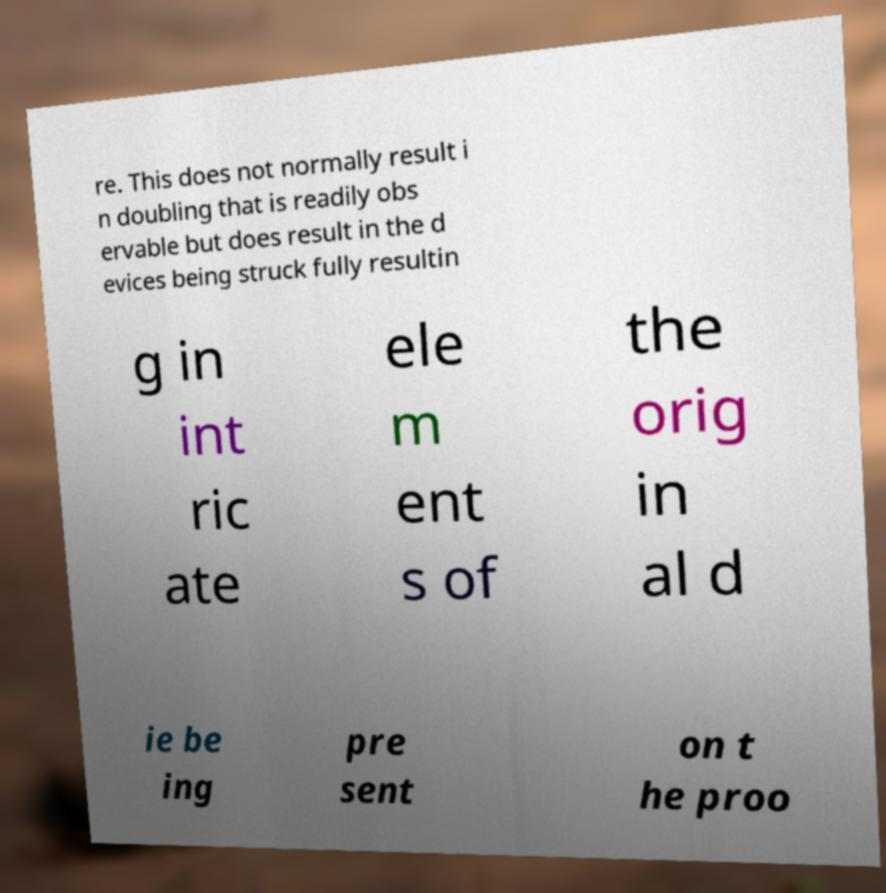Please identify and transcribe the text found in this image. re. This does not normally result i n doubling that is readily obs ervable but does result in the d evices being struck fully resultin g in int ric ate ele m ent s of the orig in al d ie be ing pre sent on t he proo 